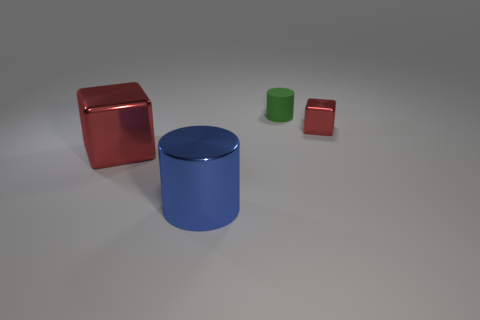What size is the metal object that is both behind the big blue cylinder and to the right of the big red metallic object?
Make the answer very short. Small. Is there a brown matte object of the same shape as the blue shiny object?
Offer a terse response. No. Is there any other thing that has the same shape as the tiny red object?
Keep it short and to the point. Yes. What material is the red cube that is left of the tiny thing that is left of the red metallic block that is behind the large red cube?
Your answer should be very brief. Metal. Are there any matte cubes that have the same size as the green thing?
Offer a terse response. No. The cylinder that is behind the metallic block in front of the small metallic block is what color?
Provide a succinct answer. Green. What number of cyan metallic balls are there?
Keep it short and to the point. 0. Is the rubber cylinder the same color as the large shiny block?
Your answer should be compact. No. Is the number of large cylinders behind the small red metallic block less than the number of big blue objects that are behind the blue metallic object?
Ensure brevity in your answer.  No. What color is the rubber cylinder?
Keep it short and to the point. Green. 